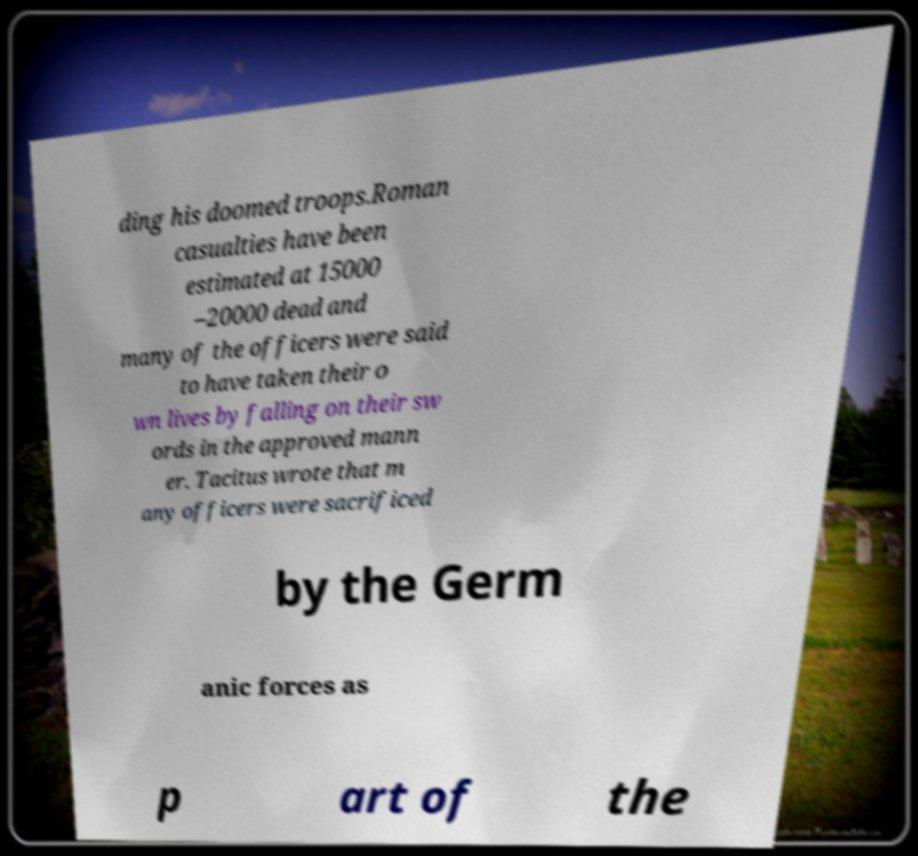Could you assist in decoding the text presented in this image and type it out clearly? ding his doomed troops.Roman casualties have been estimated at 15000 –20000 dead and many of the officers were said to have taken their o wn lives by falling on their sw ords in the approved mann er. Tacitus wrote that m any officers were sacrificed by the Germ anic forces as p art of the 